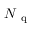Convert formula to latex. <formula><loc_0><loc_0><loc_500><loc_500>{ { N _ { q } } }</formula> 